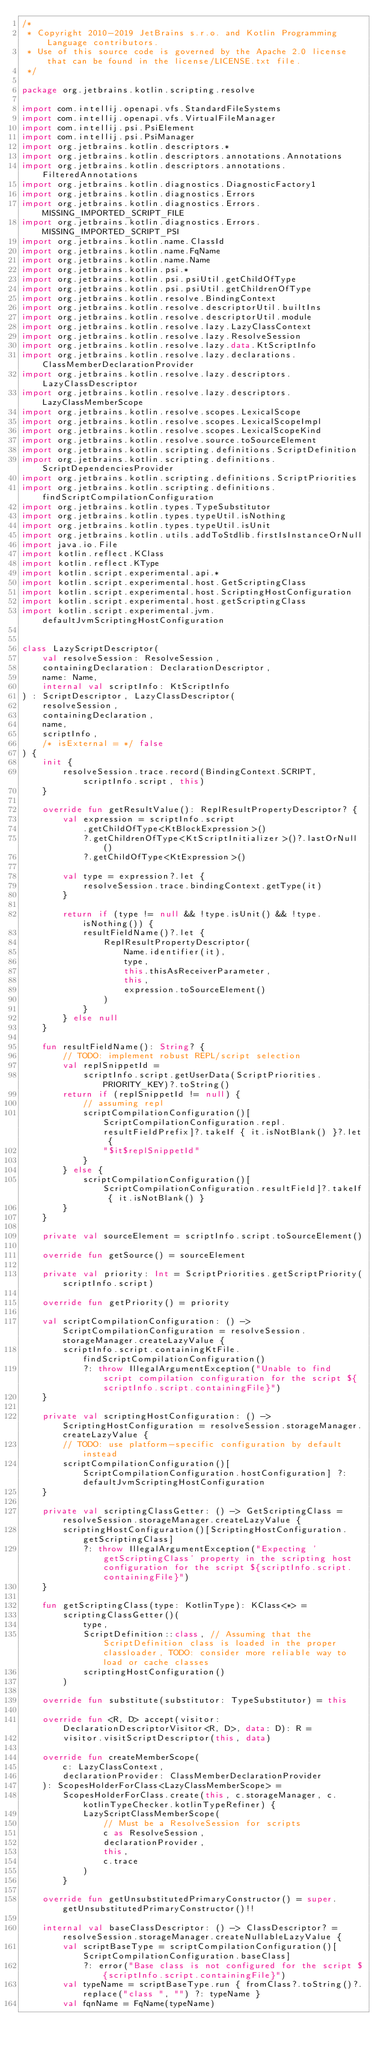Convert code to text. <code><loc_0><loc_0><loc_500><loc_500><_Kotlin_>/*
 * Copyright 2010-2019 JetBrains s.r.o. and Kotlin Programming Language contributors.
 * Use of this source code is governed by the Apache 2.0 license that can be found in the license/LICENSE.txt file.
 */

package org.jetbrains.kotlin.scripting.resolve

import com.intellij.openapi.vfs.StandardFileSystems
import com.intellij.openapi.vfs.VirtualFileManager
import com.intellij.psi.PsiElement
import com.intellij.psi.PsiManager
import org.jetbrains.kotlin.descriptors.*
import org.jetbrains.kotlin.descriptors.annotations.Annotations
import org.jetbrains.kotlin.descriptors.annotations.FilteredAnnotations
import org.jetbrains.kotlin.diagnostics.DiagnosticFactory1
import org.jetbrains.kotlin.diagnostics.Errors
import org.jetbrains.kotlin.diagnostics.Errors.MISSING_IMPORTED_SCRIPT_FILE
import org.jetbrains.kotlin.diagnostics.Errors.MISSING_IMPORTED_SCRIPT_PSI
import org.jetbrains.kotlin.name.ClassId
import org.jetbrains.kotlin.name.FqName
import org.jetbrains.kotlin.name.Name
import org.jetbrains.kotlin.psi.*
import org.jetbrains.kotlin.psi.psiUtil.getChildOfType
import org.jetbrains.kotlin.psi.psiUtil.getChildrenOfType
import org.jetbrains.kotlin.resolve.BindingContext
import org.jetbrains.kotlin.resolve.descriptorUtil.builtIns
import org.jetbrains.kotlin.resolve.descriptorUtil.module
import org.jetbrains.kotlin.resolve.lazy.LazyClassContext
import org.jetbrains.kotlin.resolve.lazy.ResolveSession
import org.jetbrains.kotlin.resolve.lazy.data.KtScriptInfo
import org.jetbrains.kotlin.resolve.lazy.declarations.ClassMemberDeclarationProvider
import org.jetbrains.kotlin.resolve.lazy.descriptors.LazyClassDescriptor
import org.jetbrains.kotlin.resolve.lazy.descriptors.LazyClassMemberScope
import org.jetbrains.kotlin.resolve.scopes.LexicalScope
import org.jetbrains.kotlin.resolve.scopes.LexicalScopeImpl
import org.jetbrains.kotlin.resolve.scopes.LexicalScopeKind
import org.jetbrains.kotlin.resolve.source.toSourceElement
import org.jetbrains.kotlin.scripting.definitions.ScriptDefinition
import org.jetbrains.kotlin.scripting.definitions.ScriptDependenciesProvider
import org.jetbrains.kotlin.scripting.definitions.ScriptPriorities
import org.jetbrains.kotlin.scripting.definitions.findScriptCompilationConfiguration
import org.jetbrains.kotlin.types.TypeSubstitutor
import org.jetbrains.kotlin.types.typeUtil.isNothing
import org.jetbrains.kotlin.types.typeUtil.isUnit
import org.jetbrains.kotlin.utils.addToStdlib.firstIsInstanceOrNull
import java.io.File
import kotlin.reflect.KClass
import kotlin.reflect.KType
import kotlin.script.experimental.api.*
import kotlin.script.experimental.host.GetScriptingClass
import kotlin.script.experimental.host.ScriptingHostConfiguration
import kotlin.script.experimental.host.getScriptingClass
import kotlin.script.experimental.jvm.defaultJvmScriptingHostConfiguration


class LazyScriptDescriptor(
    val resolveSession: ResolveSession,
    containingDeclaration: DeclarationDescriptor,
    name: Name,
    internal val scriptInfo: KtScriptInfo
) : ScriptDescriptor, LazyClassDescriptor(
    resolveSession,
    containingDeclaration,
    name,
    scriptInfo,
    /* isExternal = */ false
) {
    init {
        resolveSession.trace.record(BindingContext.SCRIPT, scriptInfo.script, this)
    }

    override fun getResultValue(): ReplResultPropertyDescriptor? {
        val expression = scriptInfo.script
            .getChildOfType<KtBlockExpression>()
            ?.getChildrenOfType<KtScriptInitializer>()?.lastOrNull()
            ?.getChildOfType<KtExpression>()

        val type = expression?.let {
            resolveSession.trace.bindingContext.getType(it)
        }

        return if (type != null && !type.isUnit() && !type.isNothing()) {
            resultFieldName()?.let {
                ReplResultPropertyDescriptor(
                    Name.identifier(it),
                    type,
                    this.thisAsReceiverParameter,
                    this,
                    expression.toSourceElement()
                )
            }
        } else null
    }

    fun resultFieldName(): String? {
        // TODO: implement robust REPL/script selection
        val replSnippetId =
            scriptInfo.script.getUserData(ScriptPriorities.PRIORITY_KEY)?.toString()
        return if (replSnippetId != null) {
            // assuming repl
            scriptCompilationConfiguration()[ScriptCompilationConfiguration.repl.resultFieldPrefix]?.takeIf { it.isNotBlank() }?.let {
                "$it$replSnippetId"
            }
        } else {
            scriptCompilationConfiguration()[ScriptCompilationConfiguration.resultField]?.takeIf { it.isNotBlank() }
        }
    }

    private val sourceElement = scriptInfo.script.toSourceElement()

    override fun getSource() = sourceElement

    private val priority: Int = ScriptPriorities.getScriptPriority(scriptInfo.script)

    override fun getPriority() = priority

    val scriptCompilationConfiguration: () -> ScriptCompilationConfiguration = resolveSession.storageManager.createLazyValue {
        scriptInfo.script.containingKtFile.findScriptCompilationConfiguration()
            ?: throw IllegalArgumentException("Unable to find script compilation configuration for the script ${scriptInfo.script.containingFile}")
    }

    private val scriptingHostConfiguration: () -> ScriptingHostConfiguration = resolveSession.storageManager.createLazyValue {
        // TODO: use platform-specific configuration by default instead
        scriptCompilationConfiguration()[ScriptCompilationConfiguration.hostConfiguration] ?: defaultJvmScriptingHostConfiguration
    }

    private val scriptingClassGetter: () -> GetScriptingClass = resolveSession.storageManager.createLazyValue {
        scriptingHostConfiguration()[ScriptingHostConfiguration.getScriptingClass]
            ?: throw IllegalArgumentException("Expecting 'getScriptingClass' property in the scripting host configuration for the script ${scriptInfo.script.containingFile}")
    }

    fun getScriptingClass(type: KotlinType): KClass<*> =
        scriptingClassGetter()(
            type,
            ScriptDefinition::class, // Assuming that the ScriptDefinition class is loaded in the proper classloader, TODO: consider more reliable way to load or cache classes
            scriptingHostConfiguration()
        )

    override fun substitute(substitutor: TypeSubstitutor) = this

    override fun <R, D> accept(visitor: DeclarationDescriptorVisitor<R, D>, data: D): R =
        visitor.visitScriptDescriptor(this, data)

    override fun createMemberScope(
        c: LazyClassContext,
        declarationProvider: ClassMemberDeclarationProvider
    ): ScopesHolderForClass<LazyClassMemberScope> =
        ScopesHolderForClass.create(this, c.storageManager, c.kotlinTypeChecker.kotlinTypeRefiner) {
            LazyScriptClassMemberScope(
                // Must be a ResolveSession for scripts
                c as ResolveSession,
                declarationProvider,
                this,
                c.trace
            )
        }

    override fun getUnsubstitutedPrimaryConstructor() = super.getUnsubstitutedPrimaryConstructor()!!

    internal val baseClassDescriptor: () -> ClassDescriptor? = resolveSession.storageManager.createNullableLazyValue {
        val scriptBaseType = scriptCompilationConfiguration()[ScriptCompilationConfiguration.baseClass]
            ?: error("Base class is not configured for the script ${scriptInfo.script.containingFile}")
        val typeName = scriptBaseType.run { fromClass?.toString()?.replace("class ", "") ?: typeName }
        val fqnName = FqName(typeName)</code> 